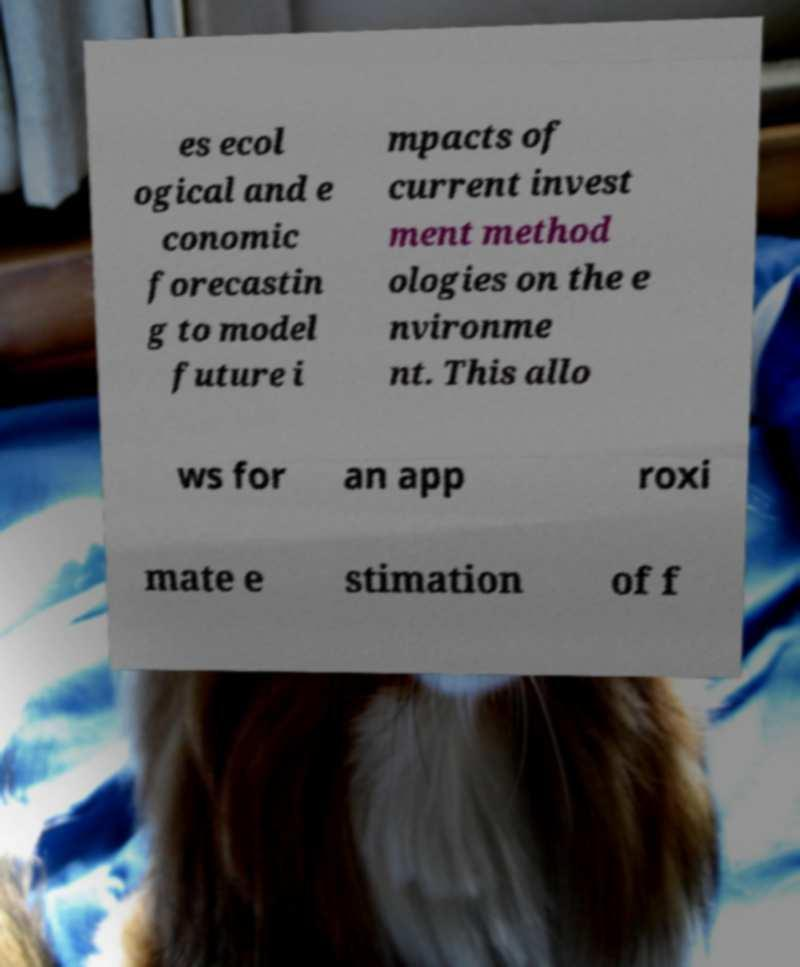Can you read and provide the text displayed in the image?This photo seems to have some interesting text. Can you extract and type it out for me? es ecol ogical and e conomic forecastin g to model future i mpacts of current invest ment method ologies on the e nvironme nt. This allo ws for an app roxi mate e stimation of f 